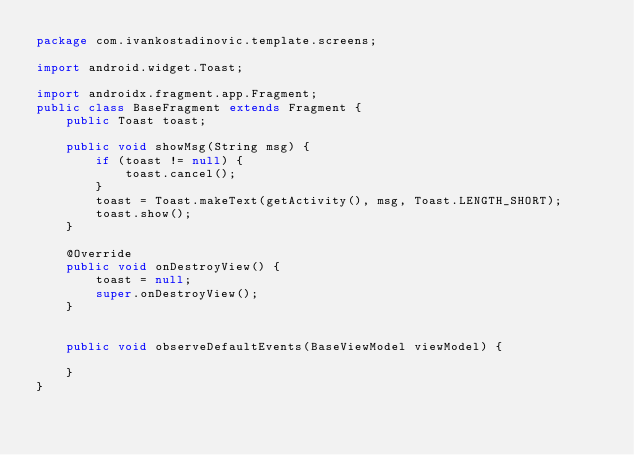Convert code to text. <code><loc_0><loc_0><loc_500><loc_500><_Java_>package com.ivankostadinovic.template.screens;

import android.widget.Toast;

import androidx.fragment.app.Fragment;
public class BaseFragment extends Fragment {
    public Toast toast;

    public void showMsg(String msg) {
        if (toast != null) {
            toast.cancel();
        }
        toast = Toast.makeText(getActivity(), msg, Toast.LENGTH_SHORT);
        toast.show();
    }

    @Override
    public void onDestroyView() {
        toast = null;
        super.onDestroyView();
    }


    public void observeDefaultEvents(BaseViewModel viewModel) {

    }
}
</code> 